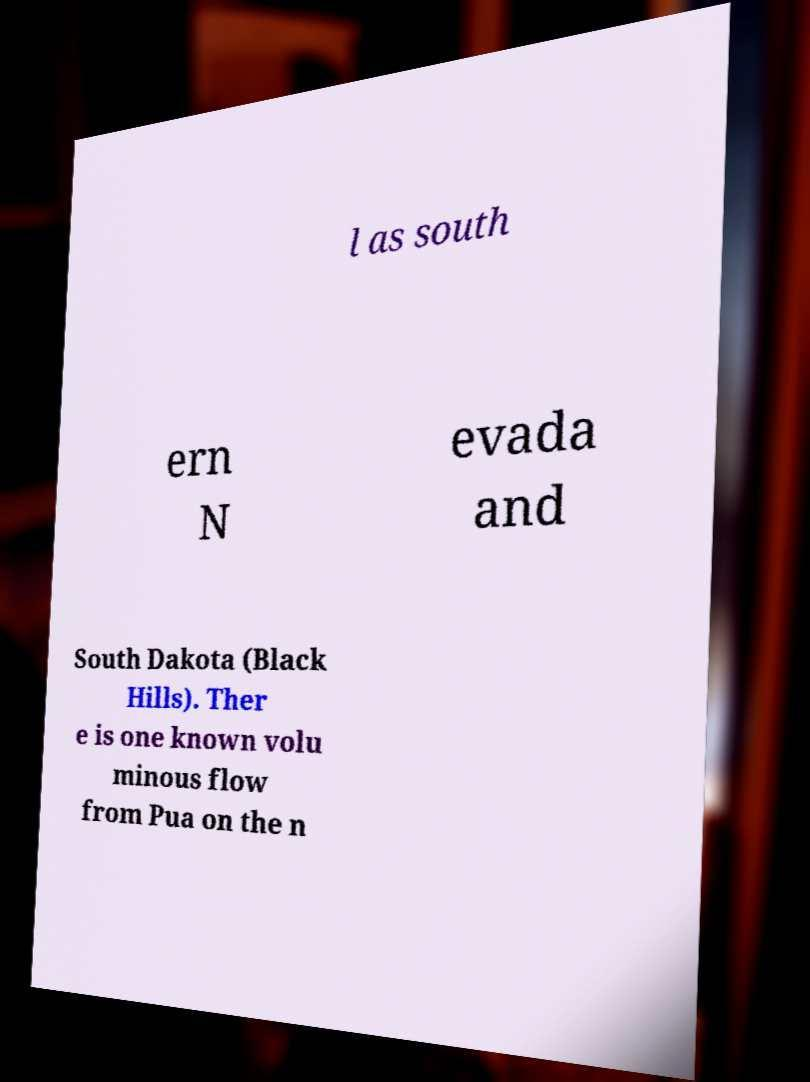I need the written content from this picture converted into text. Can you do that? l as south ern N evada and South Dakota (Black Hills). Ther e is one known volu minous flow from Pua on the n 